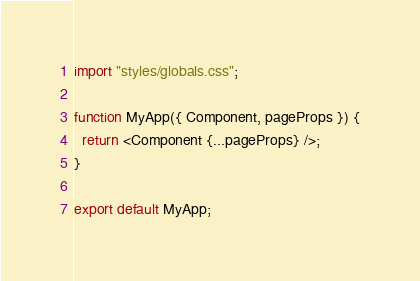<code> <loc_0><loc_0><loc_500><loc_500><_TypeScript_>import "styles/globals.css";

function MyApp({ Component, pageProps }) {
  return <Component {...pageProps} />;
}

export default MyApp;
</code> 